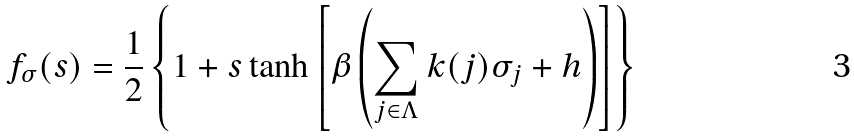<formula> <loc_0><loc_0><loc_500><loc_500>f _ { \sigma } ( s ) = \frac { 1 } { 2 } \left \{ 1 + s \tanh \left [ \beta \left ( \sum _ { j \in \Lambda } k ( j ) \sigma _ { j } + h \right ) \right ] \right \}</formula> 